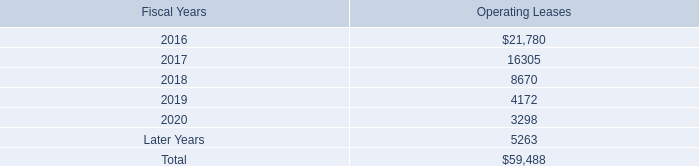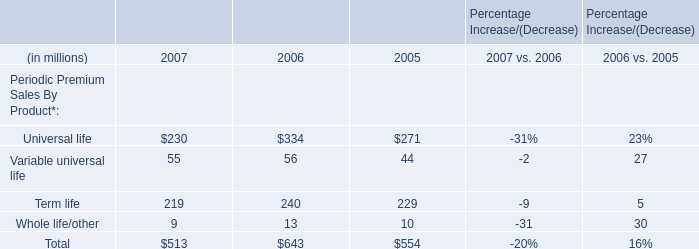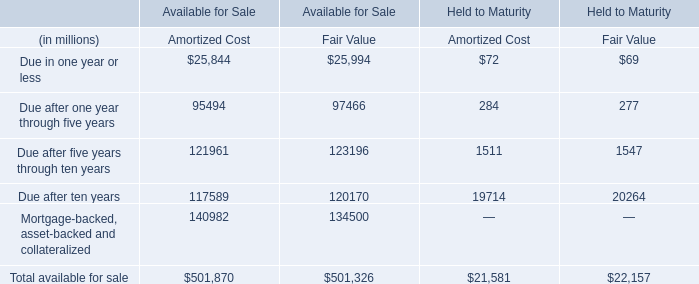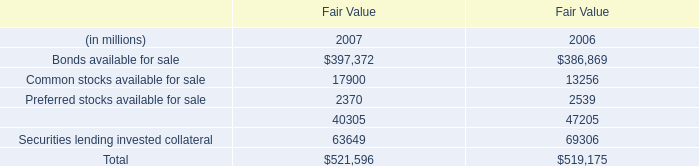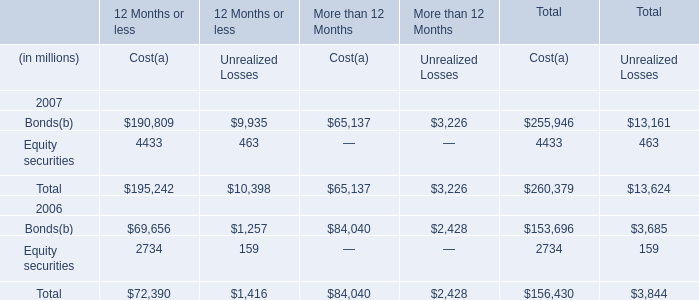Which year is Bonds available the highest? (in million) 
Answer: 2007. 